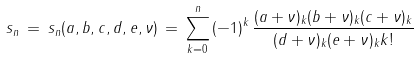Convert formula to latex. <formula><loc_0><loc_0><loc_500><loc_500>s _ { n } \, = \, s _ { n } ( a , b , c , d , e , \nu ) \, = \, \sum _ { k = 0 } ^ { n } \, ( - 1 ) ^ { k } \, \frac { ( a + \nu ) _ { k } ( b + \nu ) _ { k } ( c + \nu ) _ { k } } { ( d + \nu ) _ { k } ( e + \nu ) _ { k } k ! }</formula> 